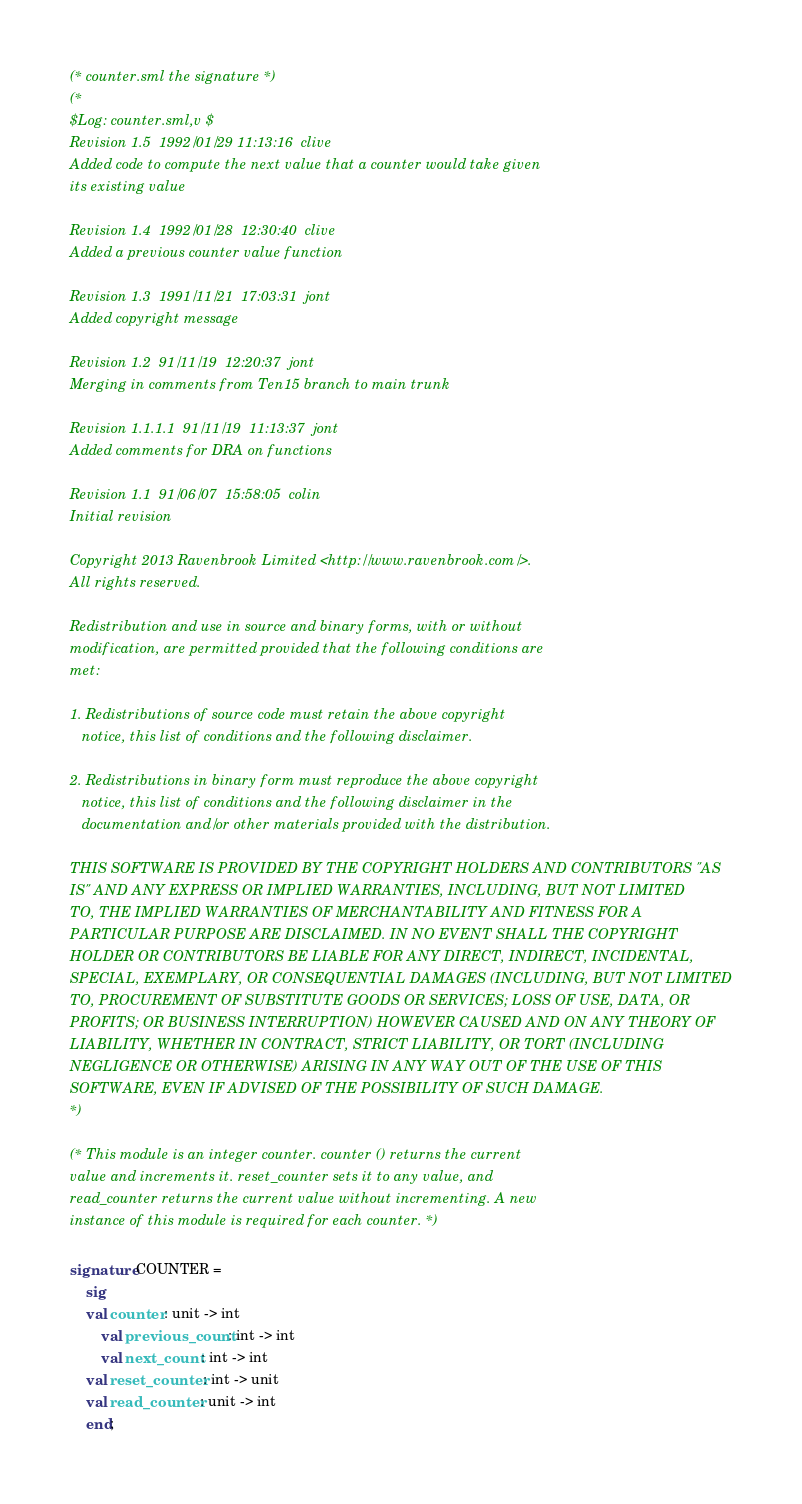Convert code to text. <code><loc_0><loc_0><loc_500><loc_500><_SML_>(* counter.sml the signature *)
(*
$Log: counter.sml,v $
Revision 1.5  1992/01/29 11:13:16  clive
Added code to compute the next value that a counter would take given
its existing value

Revision 1.4  1992/01/28  12:30:40  clive
Added a previous counter value function

Revision 1.3  1991/11/21  17:03:31  jont
Added copyright message

Revision 1.2  91/11/19  12:20:37  jont
Merging in comments from Ten15 branch to main trunk

Revision 1.1.1.1  91/11/19  11:13:37  jont
Added comments for DRA on functions

Revision 1.1  91/06/07  15:58:05  colin
Initial revision

Copyright 2013 Ravenbrook Limited <http://www.ravenbrook.com/>.
All rights reserved.

Redistribution and use in source and binary forms, with or without
modification, are permitted provided that the following conditions are
met:

1. Redistributions of source code must retain the above copyright
   notice, this list of conditions and the following disclaimer.

2. Redistributions in binary form must reproduce the above copyright
   notice, this list of conditions and the following disclaimer in the
   documentation and/or other materials provided with the distribution.

THIS SOFTWARE IS PROVIDED BY THE COPYRIGHT HOLDERS AND CONTRIBUTORS "AS
IS" AND ANY EXPRESS OR IMPLIED WARRANTIES, INCLUDING, BUT NOT LIMITED
TO, THE IMPLIED WARRANTIES OF MERCHANTABILITY AND FITNESS FOR A
PARTICULAR PURPOSE ARE DISCLAIMED. IN NO EVENT SHALL THE COPYRIGHT
HOLDER OR CONTRIBUTORS BE LIABLE FOR ANY DIRECT, INDIRECT, INCIDENTAL,
SPECIAL, EXEMPLARY, OR CONSEQUENTIAL DAMAGES (INCLUDING, BUT NOT LIMITED
TO, PROCUREMENT OF SUBSTITUTE GOODS OR SERVICES; LOSS OF USE, DATA, OR
PROFITS; OR BUSINESS INTERRUPTION) HOWEVER CAUSED AND ON ANY THEORY OF
LIABILITY, WHETHER IN CONTRACT, STRICT LIABILITY, OR TORT (INCLUDING
NEGLIGENCE OR OTHERWISE) ARISING IN ANY WAY OUT OF THE USE OF THIS
SOFTWARE, EVEN IF ADVISED OF THE POSSIBILITY OF SUCH DAMAGE.
*)

(* This module is an integer counter. counter () returns the current
value and increments it. reset_counter sets it to any value, and
read_counter returns the current value without incrementing. A new
instance of this module is required for each counter. *)

signature COUNTER =
    sig
	val counter : unit -> int
        val previous_count : int -> int
        val next_count : int -> int
	val reset_counter : int -> unit
	val read_counter : unit -> int
    end;
</code> 